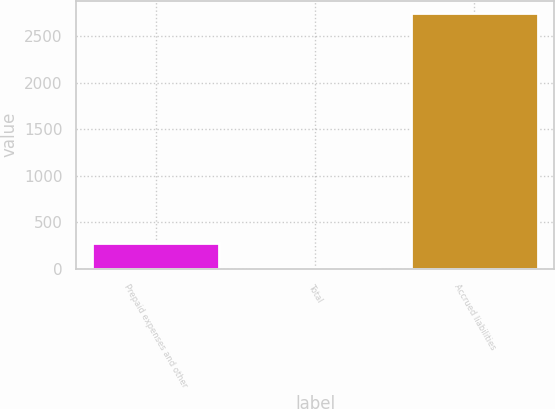Convert chart to OTSL. <chart><loc_0><loc_0><loc_500><loc_500><bar_chart><fcel>Prepaid expenses and other<fcel>Total<fcel>Accrued liabilities<nl><fcel>278.51<fcel>4.68<fcel>2743<nl></chart> 